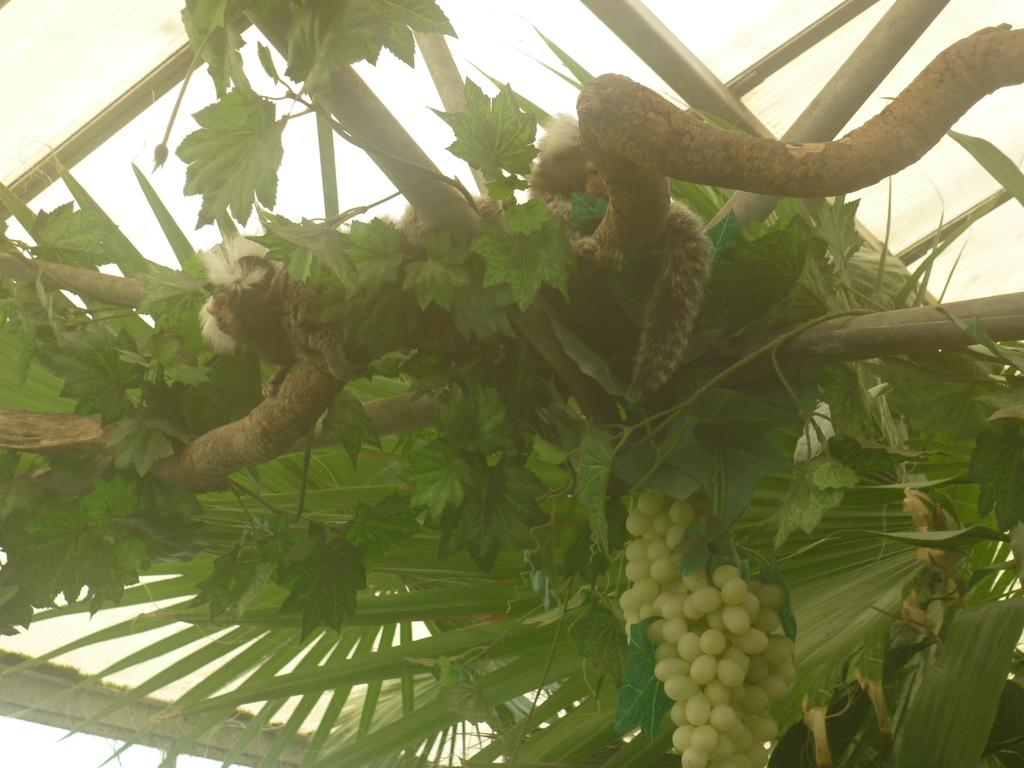What type of tree is in the image? There is a grape tree in the image. What other objects can be seen in the image? There are wooden poles visible in the image. Where are the grapes located in the image? Grapes are present at the bottom of the image. What is on the grape tree in the image? There are animals on the grape tree. What is visible at the top of the image? There is a ceiling visible at the top of the image. How does the person patch the hole in the image? There is no person or hole present in the image. 